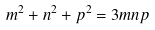<formula> <loc_0><loc_0><loc_500><loc_500>m ^ { 2 } + n ^ { 2 } + p ^ { 2 } = 3 m n p</formula> 